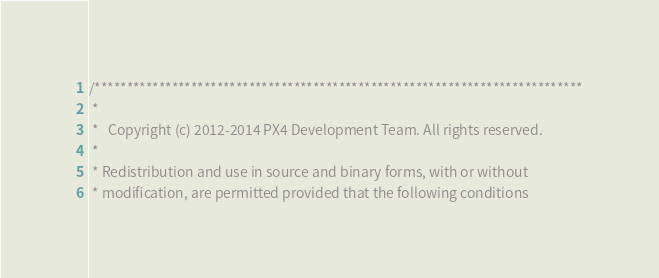<code> <loc_0><loc_0><loc_500><loc_500><_C++_>/****************************************************************************
 *
 *   Copyright (c) 2012-2014 PX4 Development Team. All rights reserved.
 *
 * Redistribution and use in source and binary forms, with or without
 * modification, are permitted provided that the following conditions</code> 